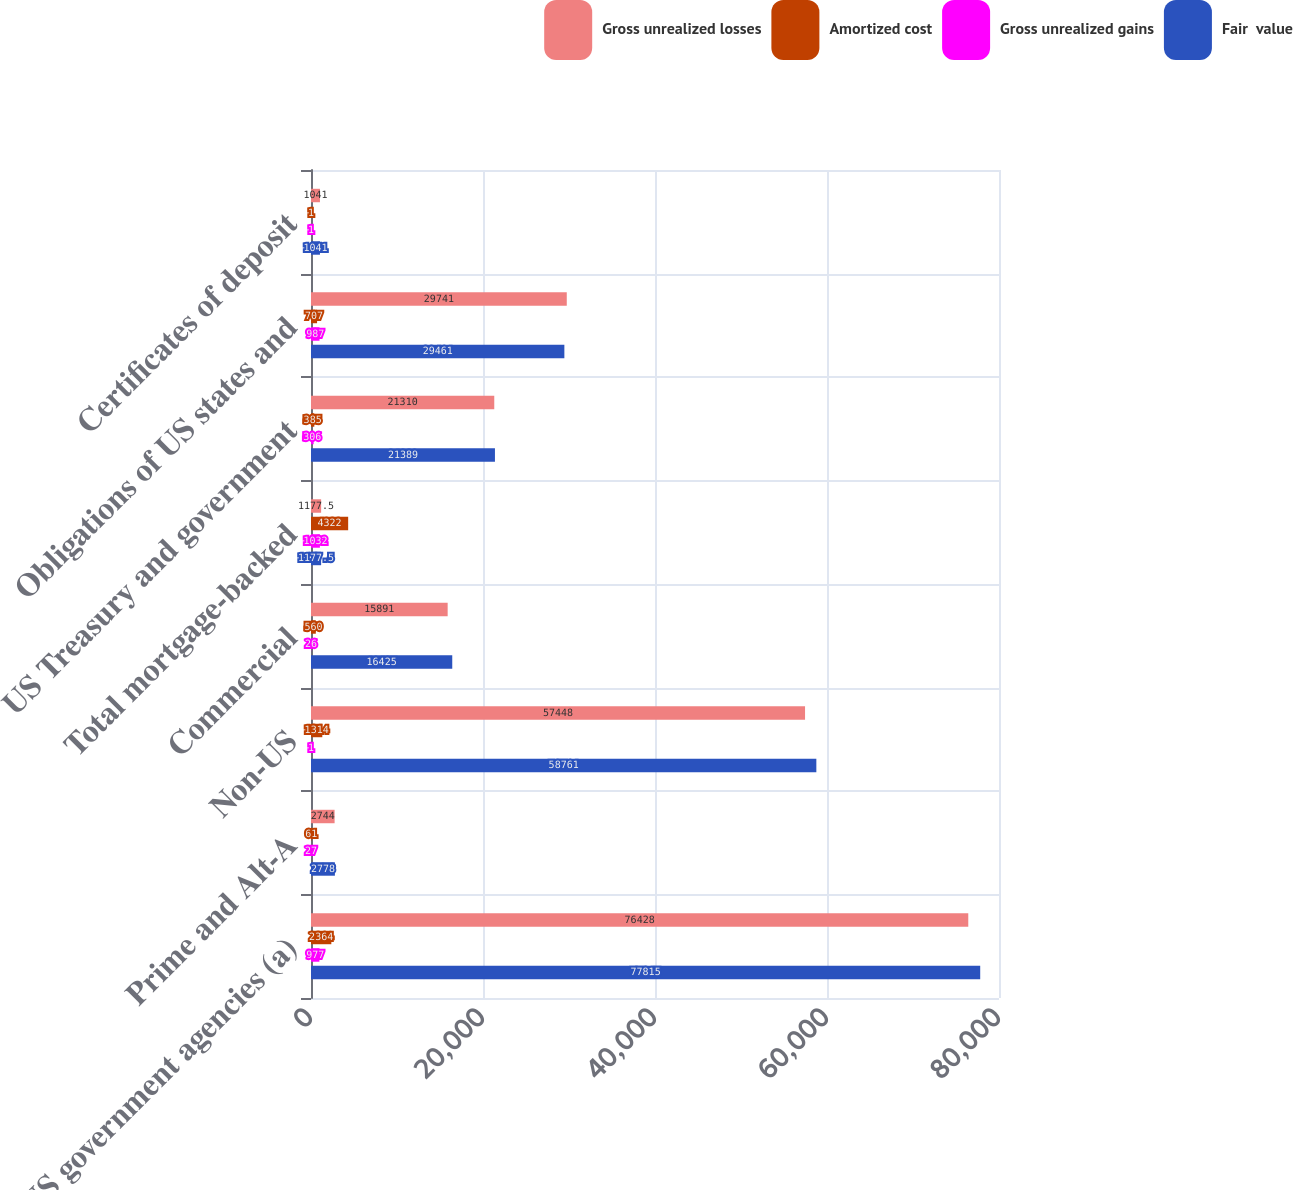Convert chart. <chart><loc_0><loc_0><loc_500><loc_500><stacked_bar_chart><ecel><fcel>US government agencies (a)<fcel>Prime and Alt-A<fcel>Non-US<fcel>Commercial<fcel>Total mortgage-backed<fcel>US Treasury and government<fcel>Obligations of US states and<fcel>Certificates of deposit<nl><fcel>Gross unrealized losses<fcel>76428<fcel>2744<fcel>57448<fcel>15891<fcel>1177.5<fcel>21310<fcel>29741<fcel>1041<nl><fcel>Amortized cost<fcel>2364<fcel>61<fcel>1314<fcel>560<fcel>4322<fcel>385<fcel>707<fcel>1<nl><fcel>Gross unrealized gains<fcel>977<fcel>27<fcel>1<fcel>26<fcel>1032<fcel>306<fcel>987<fcel>1<nl><fcel>Fair  value<fcel>77815<fcel>2778<fcel>58761<fcel>16425<fcel>1177.5<fcel>21389<fcel>29461<fcel>1041<nl></chart> 